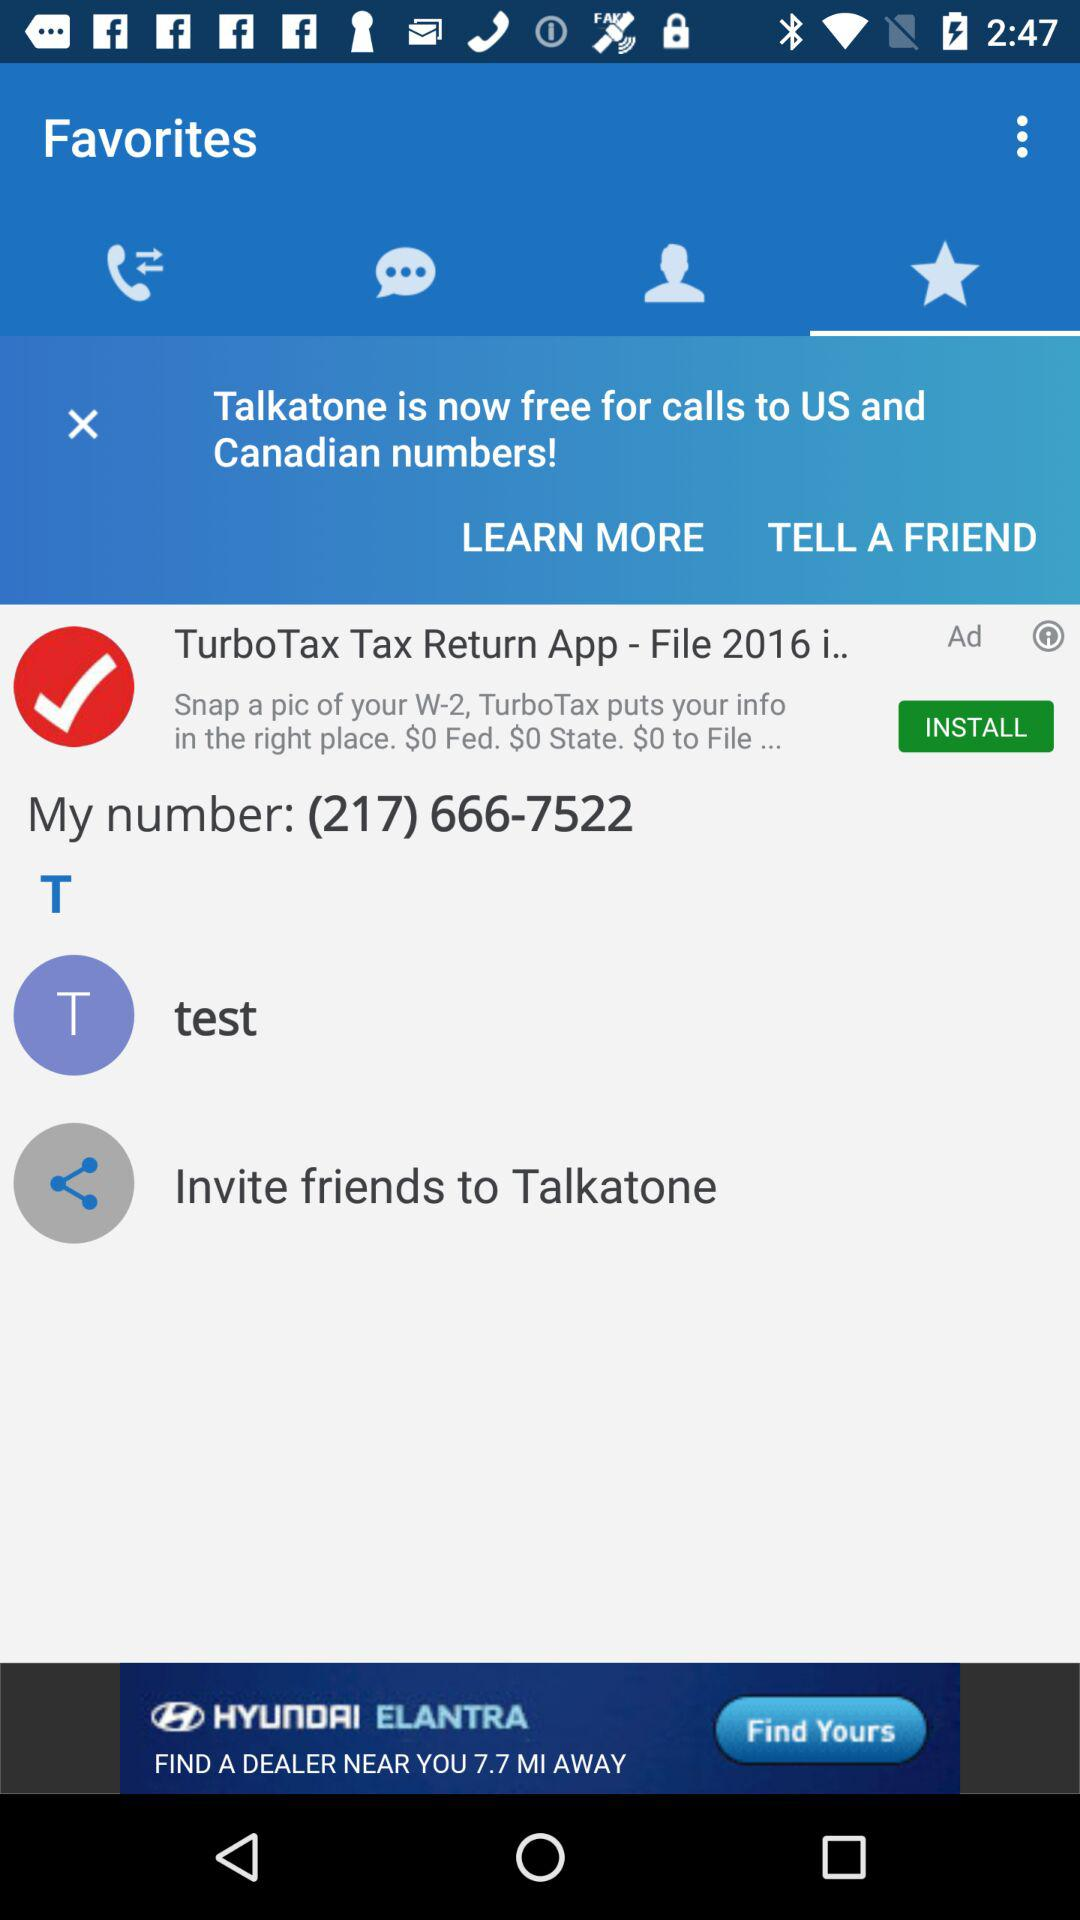What is the number? The number is (217) 666-7522. 